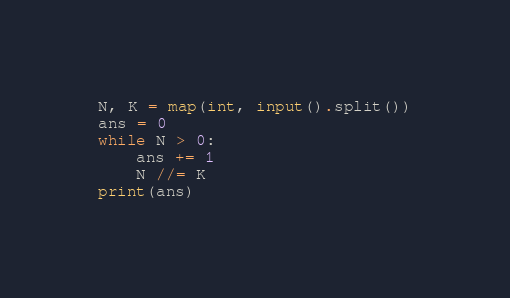Convert code to text. <code><loc_0><loc_0><loc_500><loc_500><_Python_>N, K = map(int, input().split())
ans = 0
while N > 0:
    ans += 1
    N //= K
print(ans)
</code> 